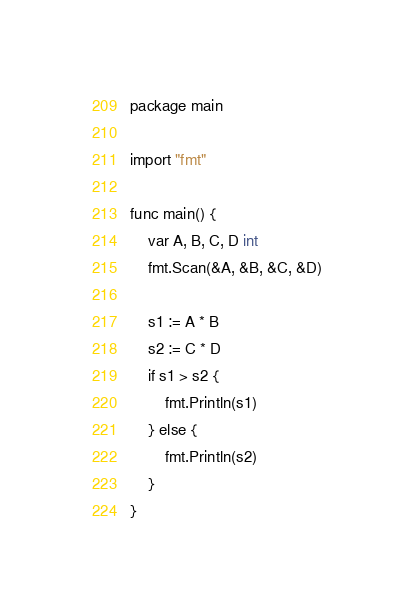Convert code to text. <code><loc_0><loc_0><loc_500><loc_500><_Go_>package main

import "fmt"

func main() {
	var A, B, C, D int
	fmt.Scan(&A, &B, &C, &D)

	s1 := A * B
	s2 := C * D
	if s1 > s2 {
		fmt.Println(s1)
	} else {
		fmt.Println(s2)
	}
}
</code> 